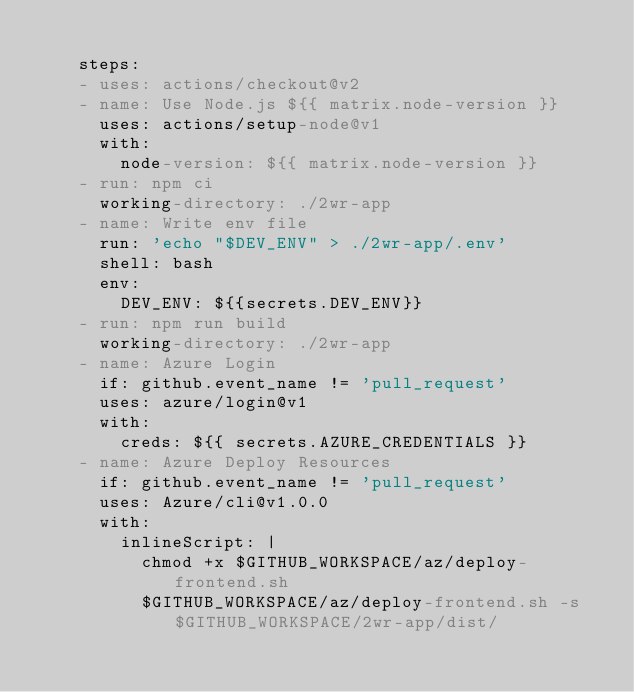Convert code to text. <code><loc_0><loc_0><loc_500><loc_500><_YAML_>
    steps:
    - uses: actions/checkout@v2
    - name: Use Node.js ${{ matrix.node-version }}
      uses: actions/setup-node@v1
      with:
        node-version: ${{ matrix.node-version }}
    - run: npm ci
      working-directory: ./2wr-app
    - name: Write env file
      run: 'echo "$DEV_ENV" > ./2wr-app/.env'
      shell: bash
      env:
        DEV_ENV: ${{secrets.DEV_ENV}}
    - run: npm run build
      working-directory: ./2wr-app
    - name: Azure Login
      if: github.event_name != 'pull_request'
      uses: azure/login@v1
      with:
        creds: ${{ secrets.AZURE_CREDENTIALS }}
    - name: Azure Deploy Resources
      if: github.event_name != 'pull_request'
      uses: Azure/cli@v1.0.0
      with:
        inlineScript: |
          chmod +x $GITHUB_WORKSPACE/az/deploy-frontend.sh
          $GITHUB_WORKSPACE/az/deploy-frontend.sh -s $GITHUB_WORKSPACE/2wr-app/dist/
</code> 